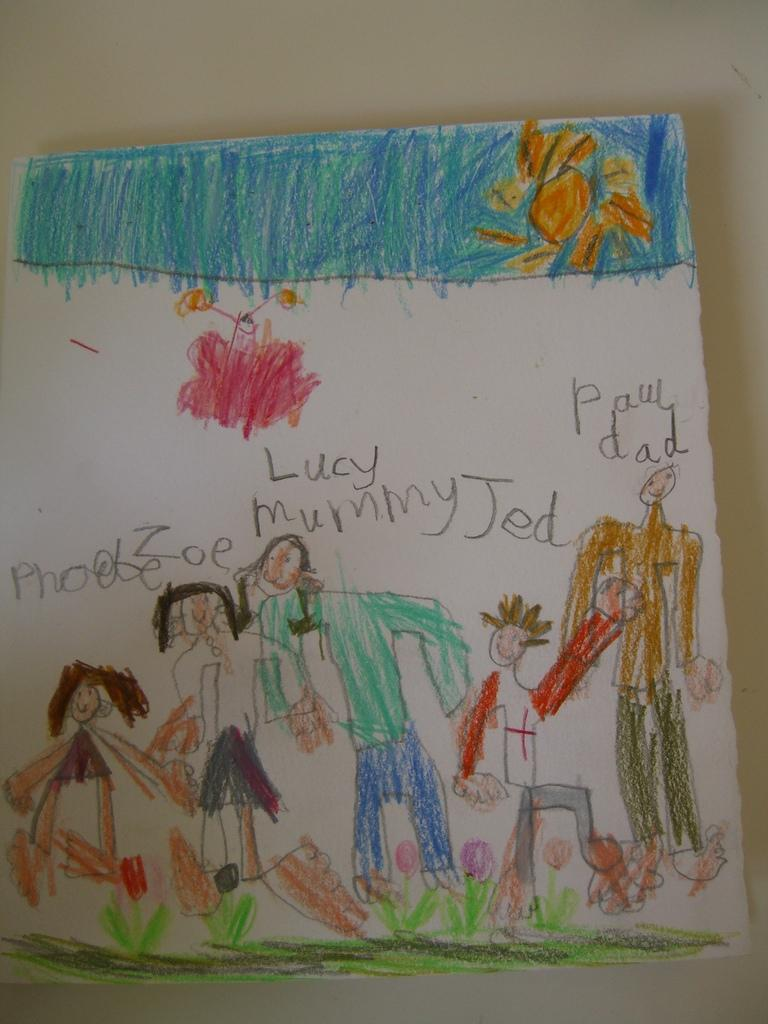What is depicted on the paper in the image? There is a drawing on the paper in the image. Where is the paper with the drawing located? The paper with the drawing appears to be on a wall in the image. What type of legal advice can be seen in the drawing on the paper? There is no legal advice or lawyer depicted in the drawing on the paper; it is simply a drawing. 